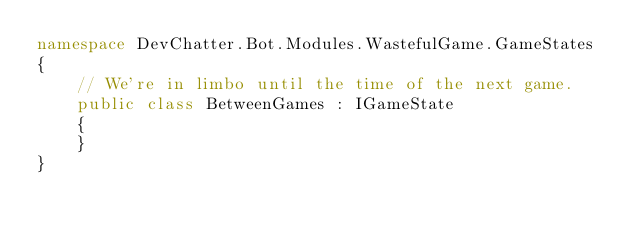<code> <loc_0><loc_0><loc_500><loc_500><_C#_>namespace DevChatter.Bot.Modules.WastefulGame.GameStates
{
    // We're in limbo until the time of the next game.
    public class BetweenGames : IGameState
    {
    }
}
</code> 